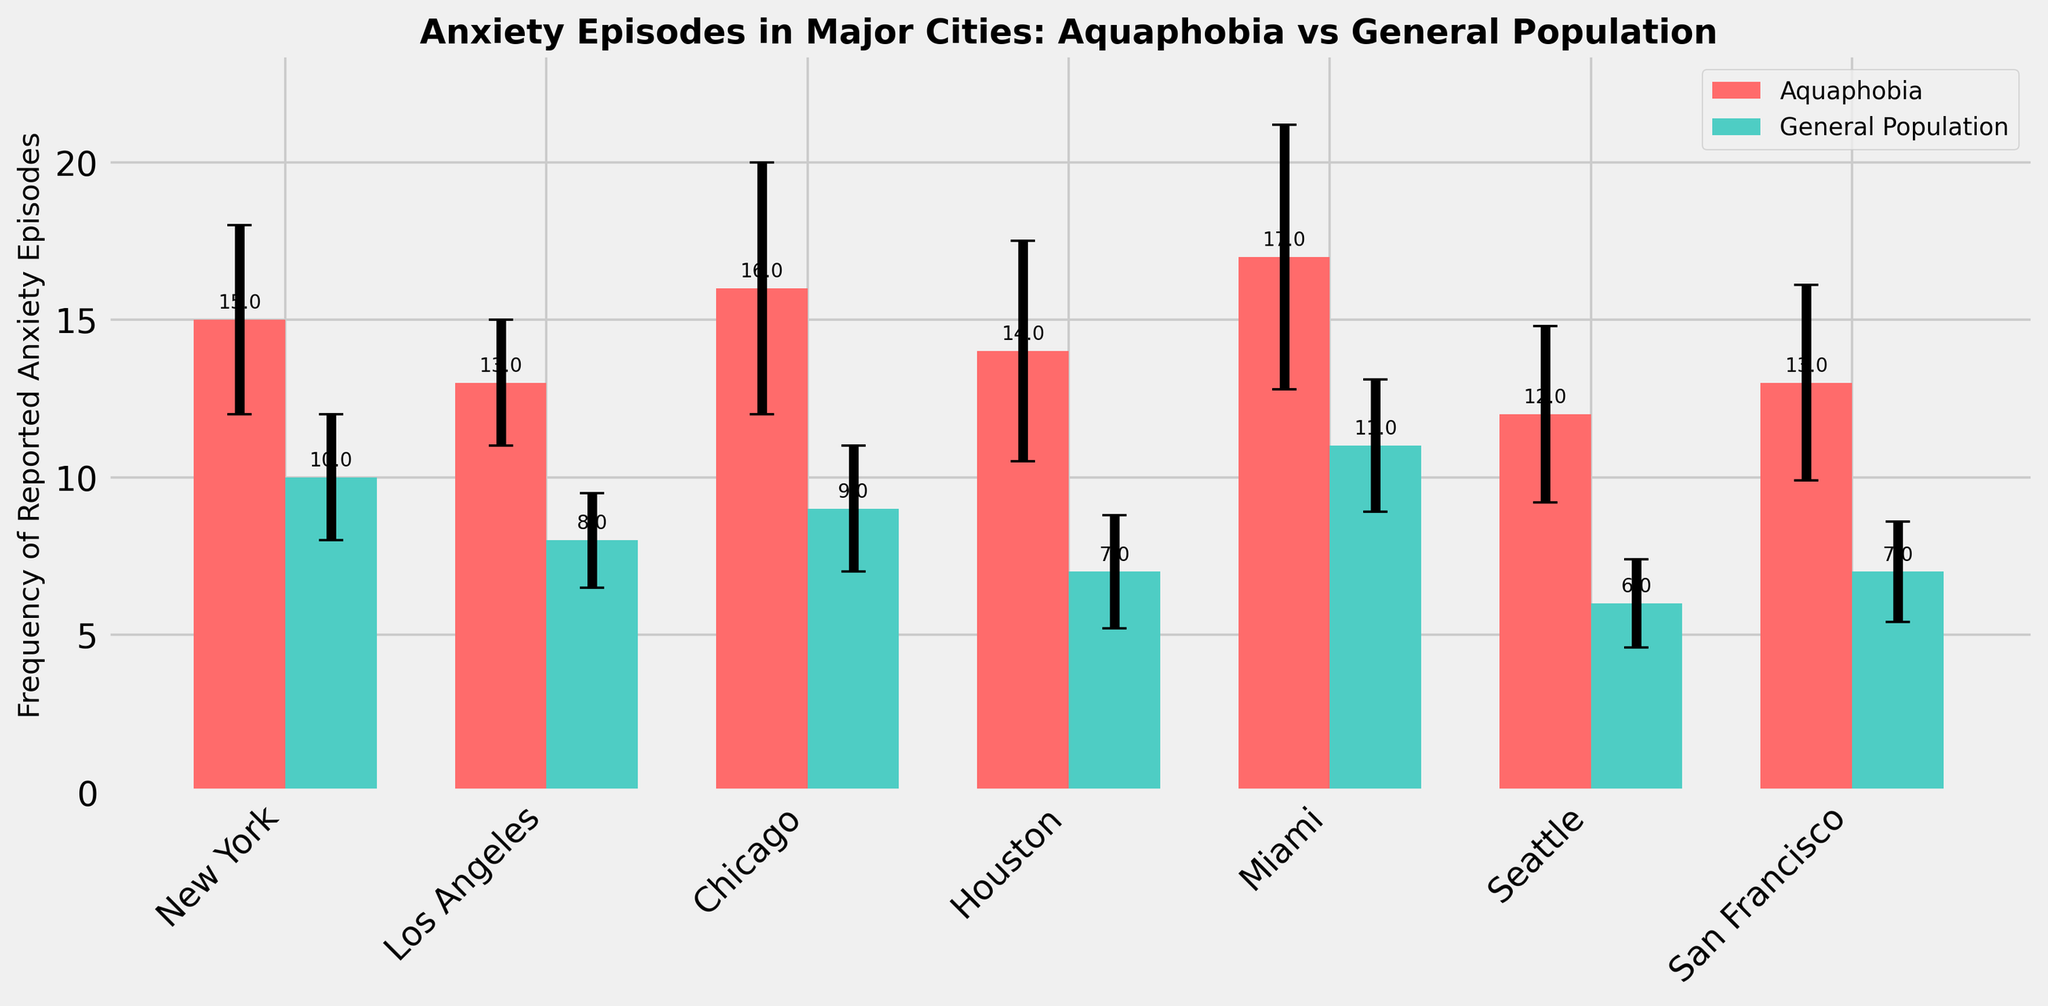What is the title of the figure? The title is printed at the top of the figure and usually describes the purpose or content of the plot. In this case, it reads, "Anxiety Episodes in Major Cities: Aquaphobia vs General Population."
Answer: Anxiety Episodes in Major Cities: Aquaphobia vs General Population Which group has the highest frequency of reported anxiety episodes in Miami? To determine this, compare the heights of the bars representing the "Aquaphobia" and "General Population" groups for Miami. The "Aquaphobia" group has a taller bar, indicating a higher frequency of reported anxiety episodes.
Answer: Aquaphobia What is the mean frequency of reported anxiety episodes for individuals with aquaphobia in Chicago? Look for the height of the bar representing the "Aquaphobia" group in Chicago. The label or the height of the bar indicates the mean frequency. It is 16.
Answer: 16 Which city shows the lowest frequency of reported anxiety episodes for the general population? Identify the shortest bar among the general population groups across all cities. The city with the shortest bar is Seattle, with a frequency of 6.
Answer: Seattle What is the difference in mean frequency of reported anxiety episodes between individuals with aquaphobia and the general population in New York? Find the heights of the bars for both groups in New York and subtract the mean frequency of the general population from that of the aquaphobia group: 15 - 10 = 5.
Answer: 5 Which city shows the biggest difference in frequency of reported anxiety episodes between individuals with aquaphobia and the general population? Calculate the difference in frequency for each city by subtracting the general population bar height from the aquaphobia bar height. Miami has the biggest difference: 17 (aquaphobia) - 11 (general) = 6.
Answer: Miami What is the error margin (standard deviation) for the aquaphobia group in Houston? Look for the error bars extending from the top of the bar representing the "Aquaphobia" group in Houston. The label associated with it indicates an error margin of 3.5.
Answer: 3.5 If we average the mean frequency of reported anxiety episodes for the general population across all cities, what is the result? Sum the mean frequencies for the general population from each city (10, 8, 9, 7, 11, 6, 7) and divide by the number of cities (7): (10 + 8 + 9 + 7 + 11 + 6 + 7) / 7 = 8.29.
Answer: 8.29 Which group shows more variability in frequency of reported anxiety episodes in San Francisco, aquaphobia or general population? Compare the lengths of the error bars (standard deviations) for each group in San Francisco. The aquaphobia group has a standard deviation of 3.1, while the general population has 1.6, indicating more variability in the aquaphobia group.
Answer: Aquaphobia 